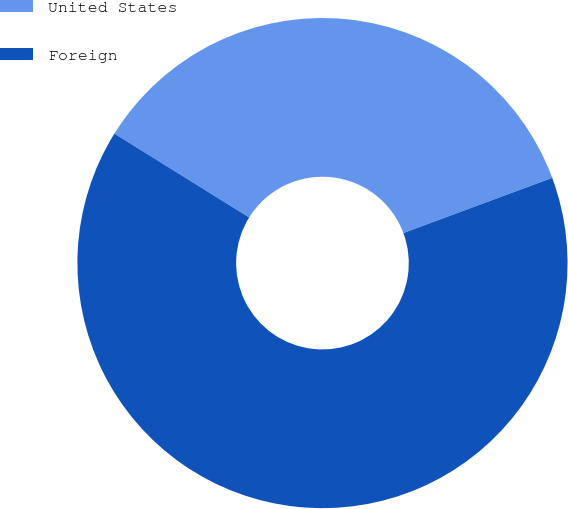Convert chart. <chart><loc_0><loc_0><loc_500><loc_500><pie_chart><fcel>United States<fcel>Foreign<nl><fcel>35.49%<fcel>64.51%<nl></chart> 